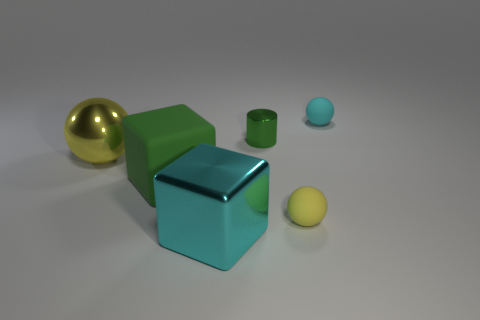Add 1 green matte objects. How many objects exist? 7 Subtract all blocks. How many objects are left? 4 Subtract all large matte blocks. Subtract all purple cylinders. How many objects are left? 5 Add 1 small cylinders. How many small cylinders are left? 2 Add 4 large cyan matte spheres. How many large cyan matte spheres exist? 4 Subtract 0 red blocks. How many objects are left? 6 